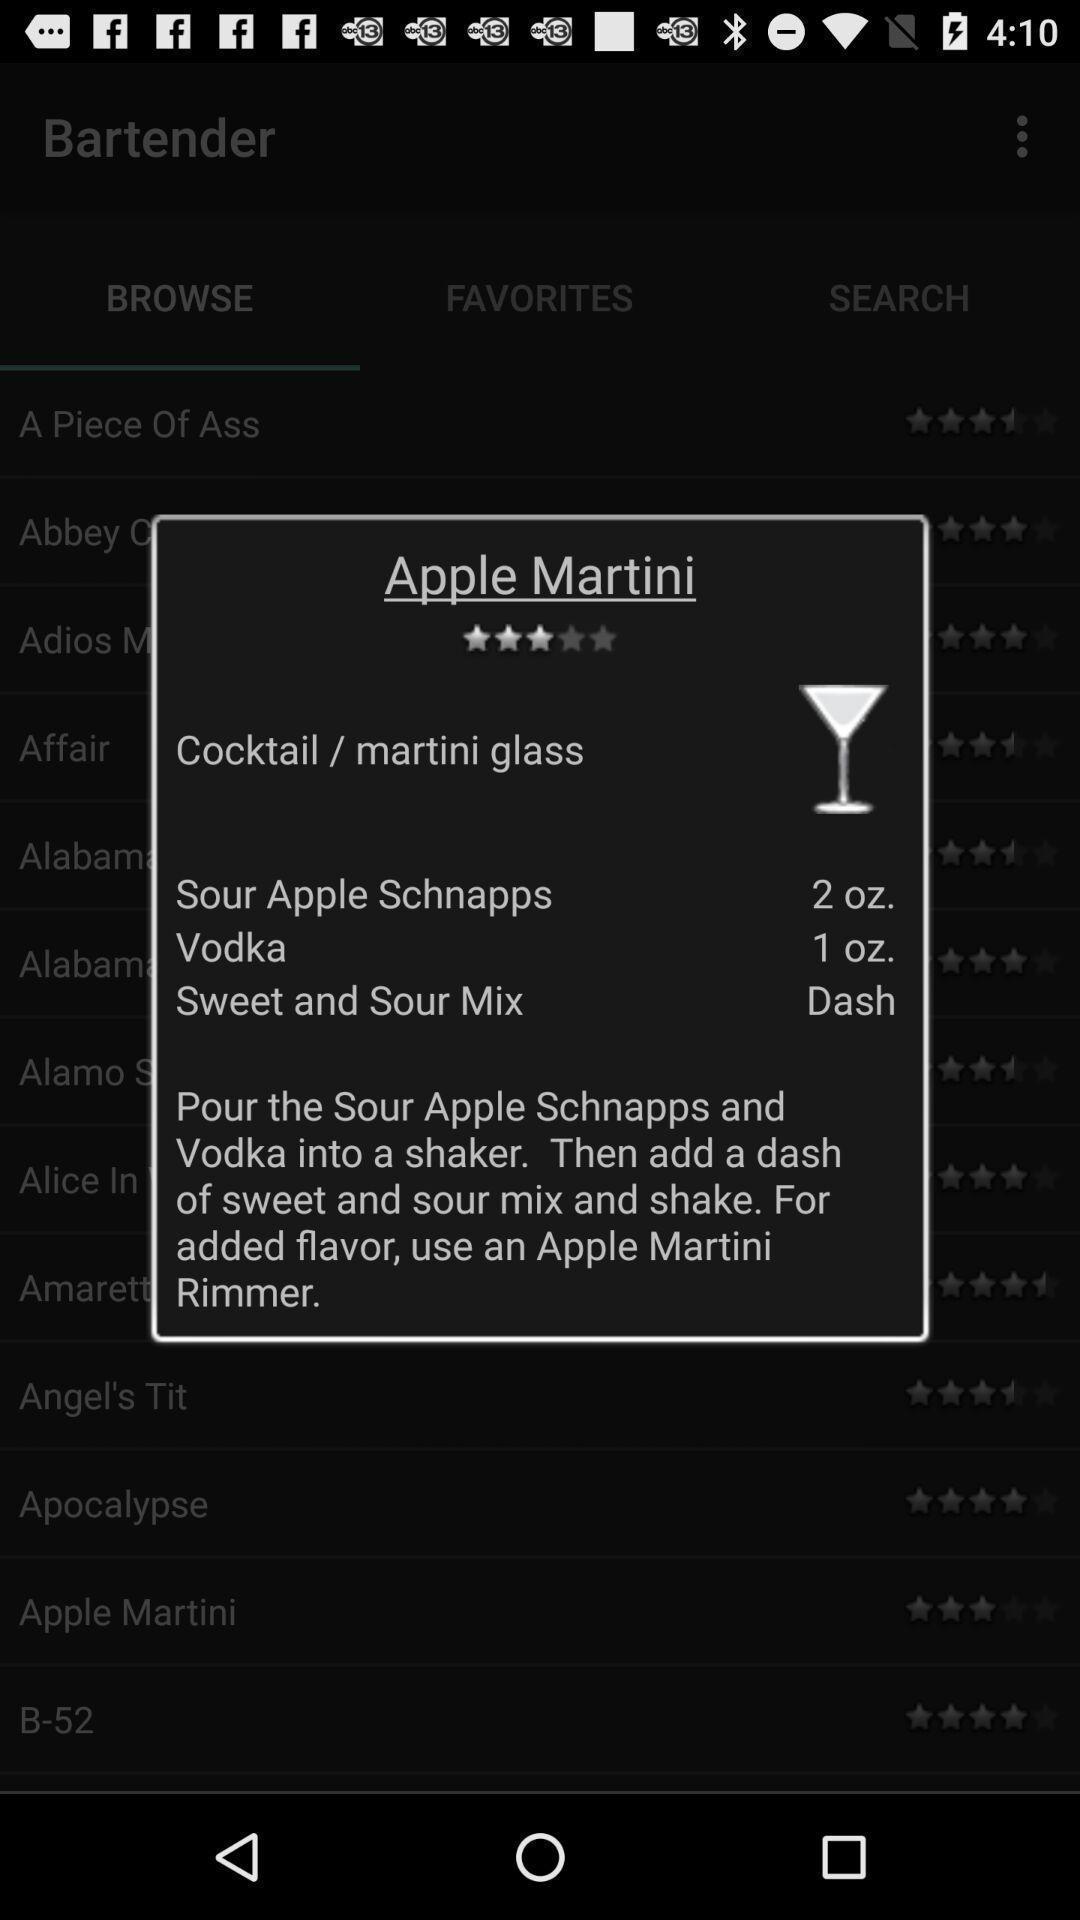What can you discern from this picture? Pop-up for making the drink using apple schnapps and vodka. 